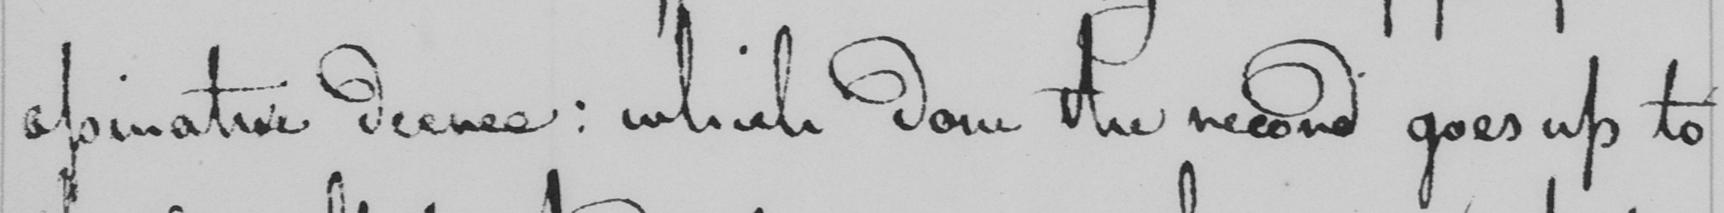Please provide the text content of this handwritten line. apinative decree :  which done the record goes up to 